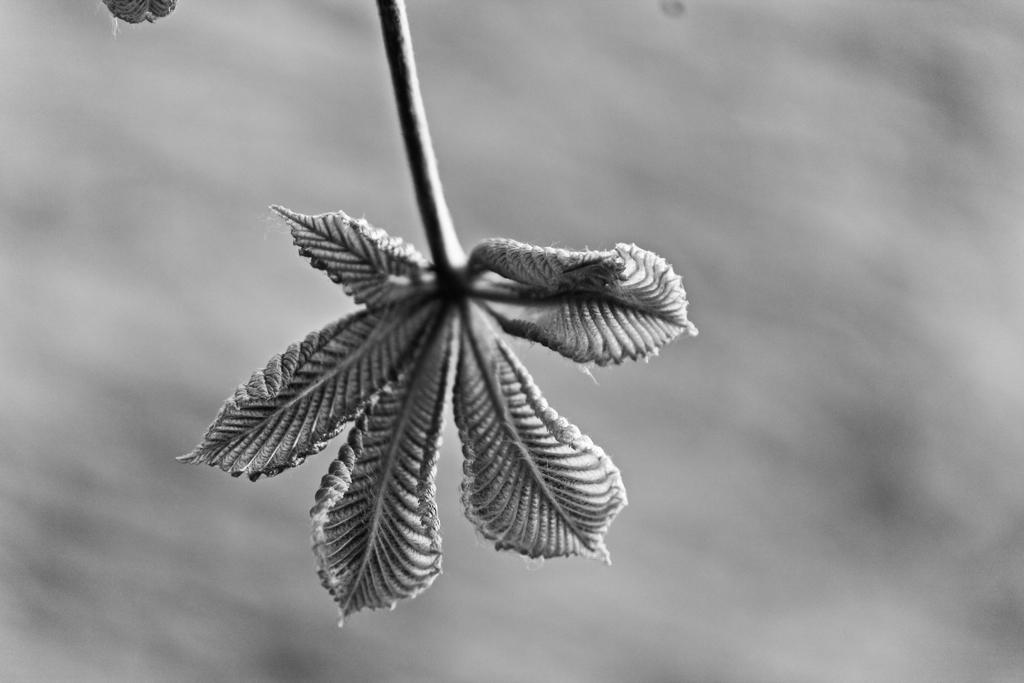What is the main subject of the image? There is a flower in the image. What color scheme is used in the image? The image is black and white. What type of jar is visible in the image? There is no jar present in the image; it features a flower in a black and white color scheme. What degree of education does the flower have in the image? The flower is not a living being and therefore cannot have a degree of education. 